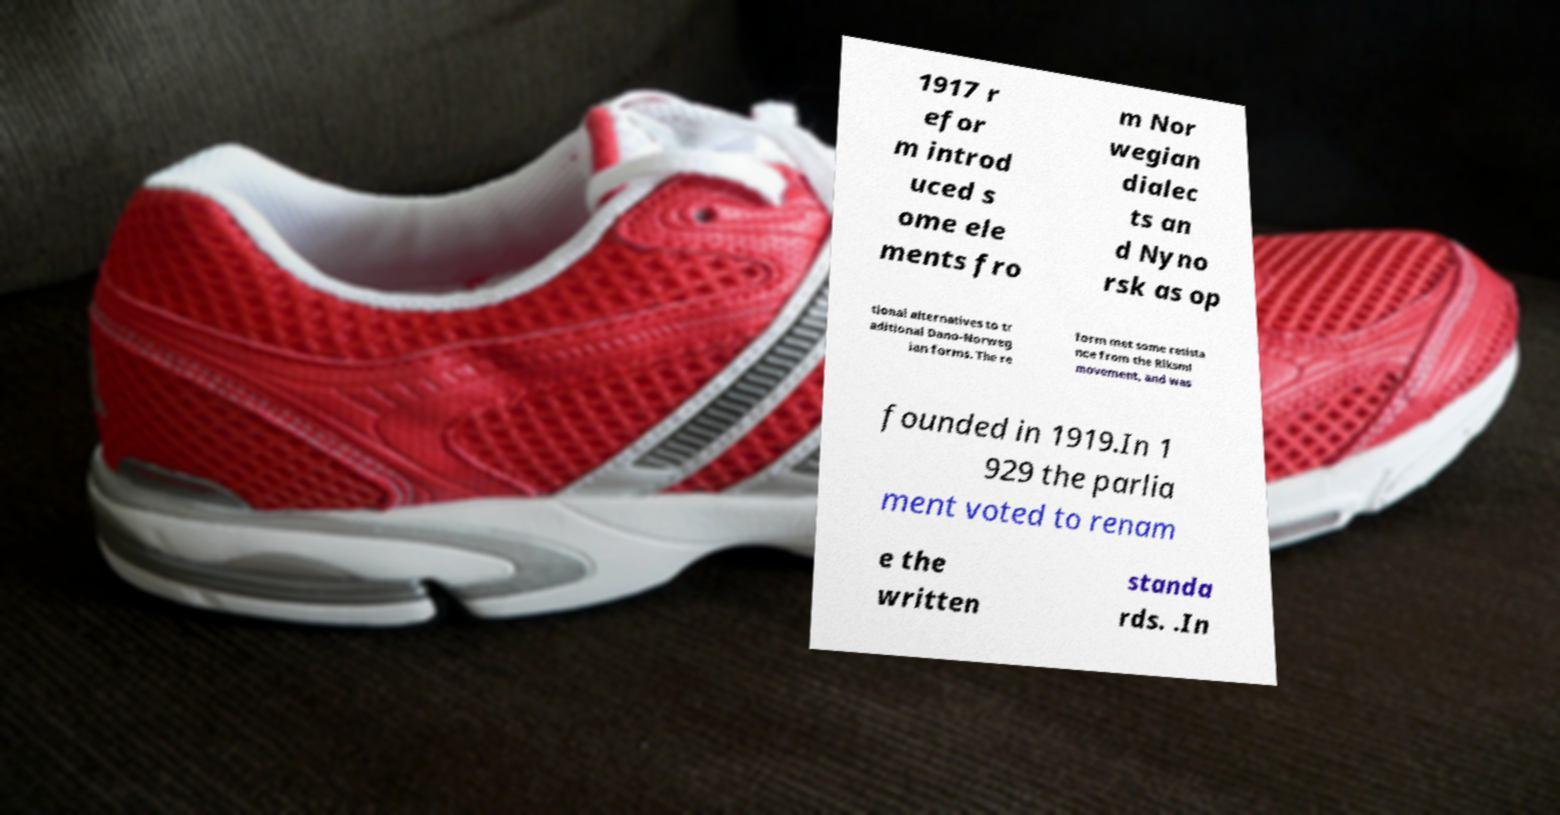What messages or text are displayed in this image? I need them in a readable, typed format. 1917 r efor m introd uced s ome ele ments fro m Nor wegian dialec ts an d Nyno rsk as op tional alternatives to tr aditional Dano-Norweg ian forms. The re form met some resista nce from the Riksml movement, and was founded in 1919.In 1 929 the parlia ment voted to renam e the written standa rds. .In 